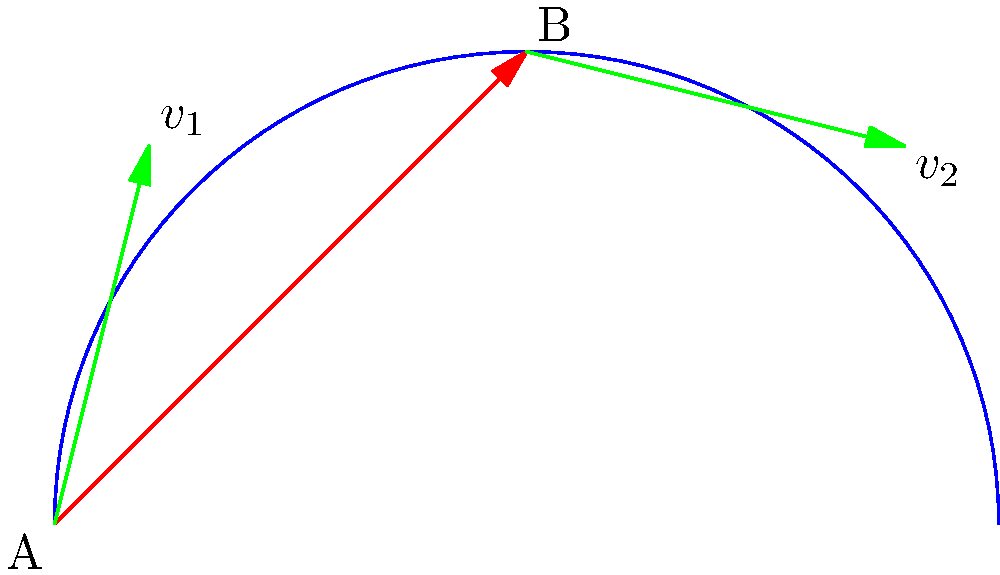Consider the curved path shown in the figure, with points A and B connected by a red arrow. Two vectors $v_1$ and $v_2$ are shown at points A and B respectively. If $v_2$ is the result of parallel transport of $v_1$ along the curve from A to B, what property must be satisfied in Riemannian geometry? To understand parallel transport in Riemannian geometry, we need to follow these steps:

1) In Riemannian geometry, parallel transport preserves the inner product of vectors.

2) The inner product of two vectors in Riemannian geometry is defined using the metric tensor $g_{ij}$:
   $$\langle u, v \rangle = g_{ij}u^i v^j$$

3) For parallel transport, this inner product must be preserved along the curve. Mathematically:
   $$\langle v_1, v_1 \rangle_A = \langle v_2, v_2 \rangle_B$$

4) This means that the length of the vector and its angle with respect to the tangent of the curve should remain constant during transport.

5) In terms of covariant derivative, parallel transport is described by the equation:
   $$\frac{D v^i}{d\lambda} = 0$$
   where $\frac{D}{d\lambda}$ is the covariant derivative along the curve.

6) This equation ensures that the change in the vector components exactly compensates for the change in the coordinate basis along the curve.

7) As a result, while the components of the vector may change in a coordinate-dependent way, its geometric properties (like length and angle with the curve) remain invariant.

Therefore, the key property that must be satisfied is the preservation of the inner product, which geometrically translates to preserving the vector's length and its angle with the curve's tangent.
Answer: Preservation of inner product 